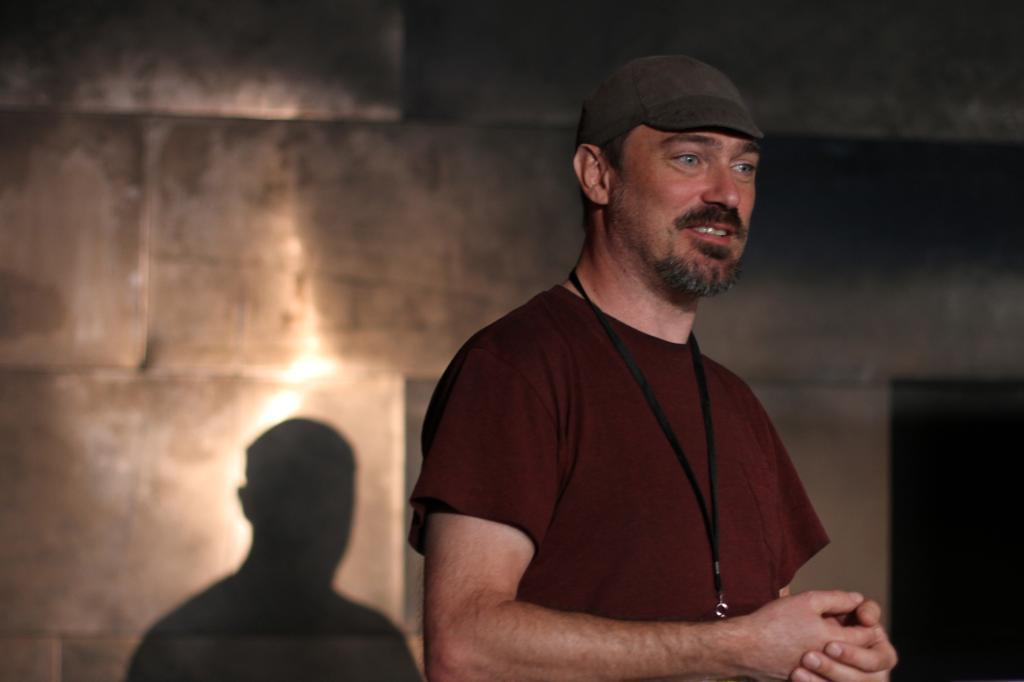What is the main subject of the image? There is a man in the image. What is the man wearing on his upper body? The man is wearing a brown T-shirt. What type of headwear is the man wearing? The man is wearing a cap. What can be seen in the background of the image? There is a wall in the background of the image, and a shadow is visible on the wall. What architectural feature is present on the right side of the image? There appears to be a door on the right side of the image. What type of butter is being used to paint the door in the image? There is no butter present in the image, and the door is not being painted. How many fifths are visible in the image? The term "fifth" does not apply to any elements in the image, as it typically refers to a fraction or a type of liquor. 